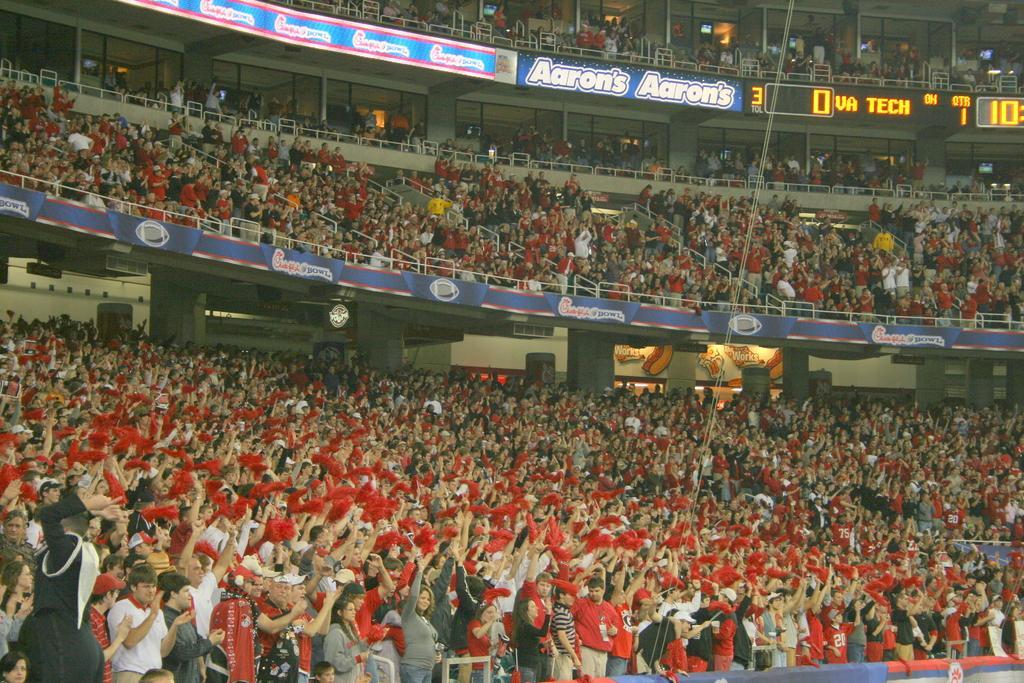Could you give a brief overview of what you see in this image? In this picture I can see there are a huge number of audience and they have a red cloth in their hands and I can see there are some banners and screens. 